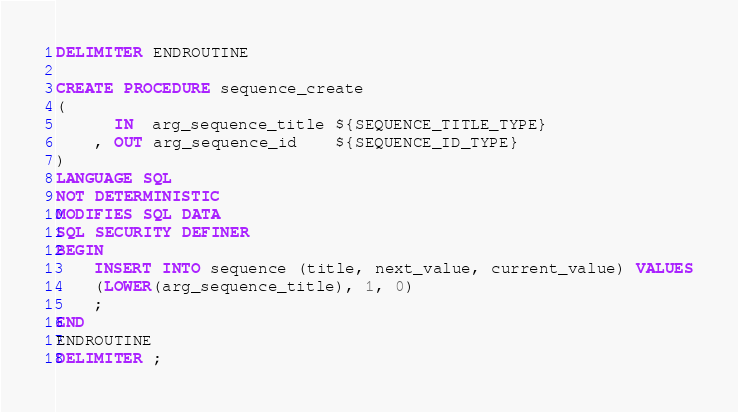<code> <loc_0><loc_0><loc_500><loc_500><_SQL_>DELIMITER ENDROUTINE

CREATE PROCEDURE sequence_create
(
      IN  arg_sequence_title ${SEQUENCE_TITLE_TYPE}
    , OUT arg_sequence_id    ${SEQUENCE_ID_TYPE}
)
LANGUAGE SQL
NOT DETERMINISTIC
MODIFIES SQL DATA
SQL SECURITY DEFINER
BEGIN
    INSERT INTO sequence (title, next_value, current_value) VALUES
    (LOWER(arg_sequence_title), 1, 0)
    ;
END
ENDROUTINE
DELIMITER ;
</code> 